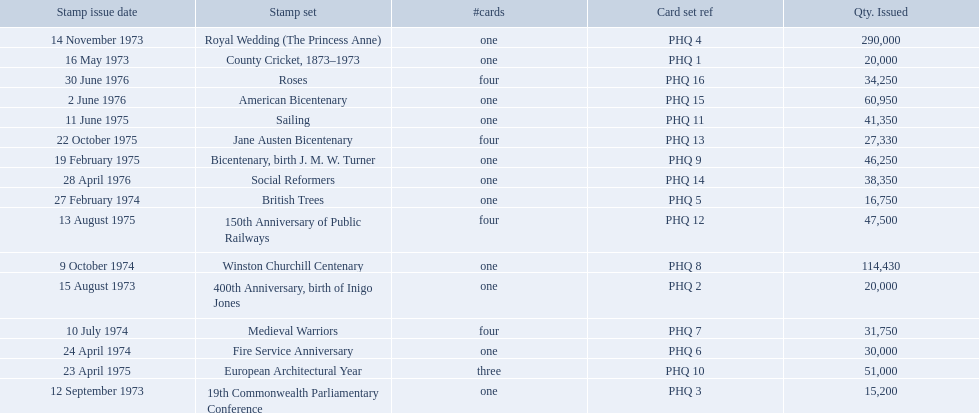What are all the stamp sets? County Cricket, 1873–1973, 400th Anniversary, birth of Inigo Jones, 19th Commonwealth Parliamentary Conference, Royal Wedding (The Princess Anne), British Trees, Fire Service Anniversary, Medieval Warriors, Winston Churchill Centenary, Bicentenary, birth J. M. W. Turner, European Architectural Year, Sailing, 150th Anniversary of Public Railways, Jane Austen Bicentenary, Social Reformers, American Bicentenary, Roses. For these sets, what were the quantities issued? 20,000, 20,000, 15,200, 290,000, 16,750, 30,000, 31,750, 114,430, 46,250, 51,000, 41,350, 47,500, 27,330, 38,350, 60,950, 34,250. Of these, which quantity is above 200,000? 290,000. What is the stamp set corresponding to this quantity? Royal Wedding (The Princess Anne). 